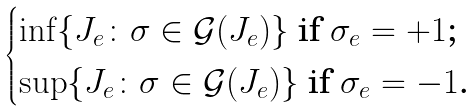<formula> <loc_0><loc_0><loc_500><loc_500>\begin{cases} \inf \{ J _ { e } \colon \sigma \in \mathcal { G } ( J _ { e } ) \} \text { if $\sigma_{e}=+1$;} \\ \sup \{ J _ { e } \colon \sigma \in \mathcal { G } ( J _ { e } ) \} \text { if $\sigma_{e}=-1$.} \end{cases}</formula> 